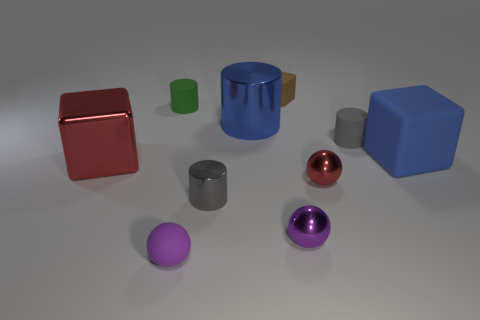Subtract 1 cylinders. How many cylinders are left? 3 Subtract all yellow cylinders. Subtract all brown cubes. How many cylinders are left? 4 Subtract all cylinders. How many objects are left? 6 Subtract all big blue spheres. Subtract all large blue objects. How many objects are left? 8 Add 1 tiny rubber blocks. How many tiny rubber blocks are left? 2 Add 7 green spheres. How many green spheres exist? 7 Subtract 0 green spheres. How many objects are left? 10 